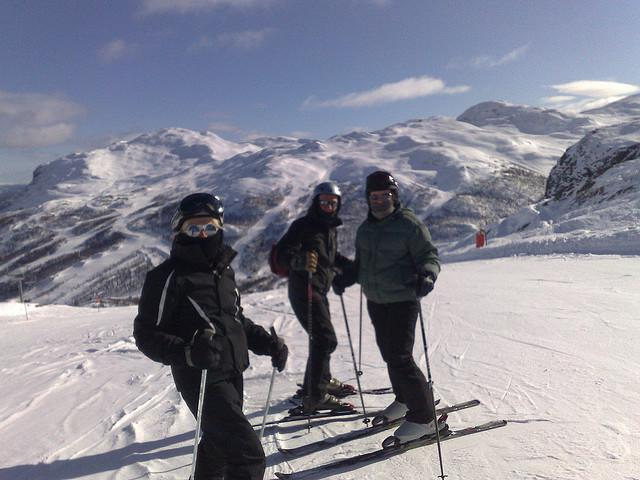Why are these people covering their faces? Please explain your reasoning. keeping warm. They are in the snow which is cold. 